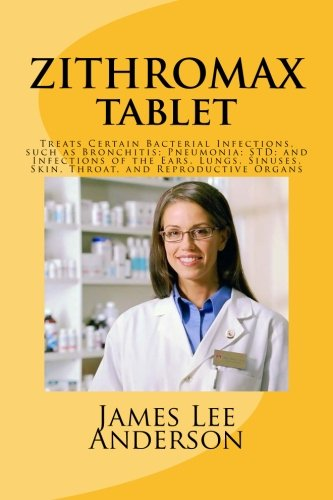Is this a digital technology book? No, this book has no relation to digital technology. It is a reference guide on the antibiotic Zithromax and its applications in treating bacterial infections. 